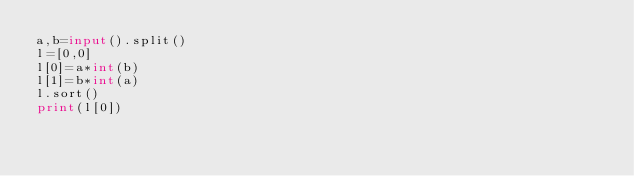Convert code to text. <code><loc_0><loc_0><loc_500><loc_500><_Python_>a,b=input().split()
l=[0,0]
l[0]=a*int(b)
l[1]=b*int(a)
l.sort()
print(l[0])</code> 